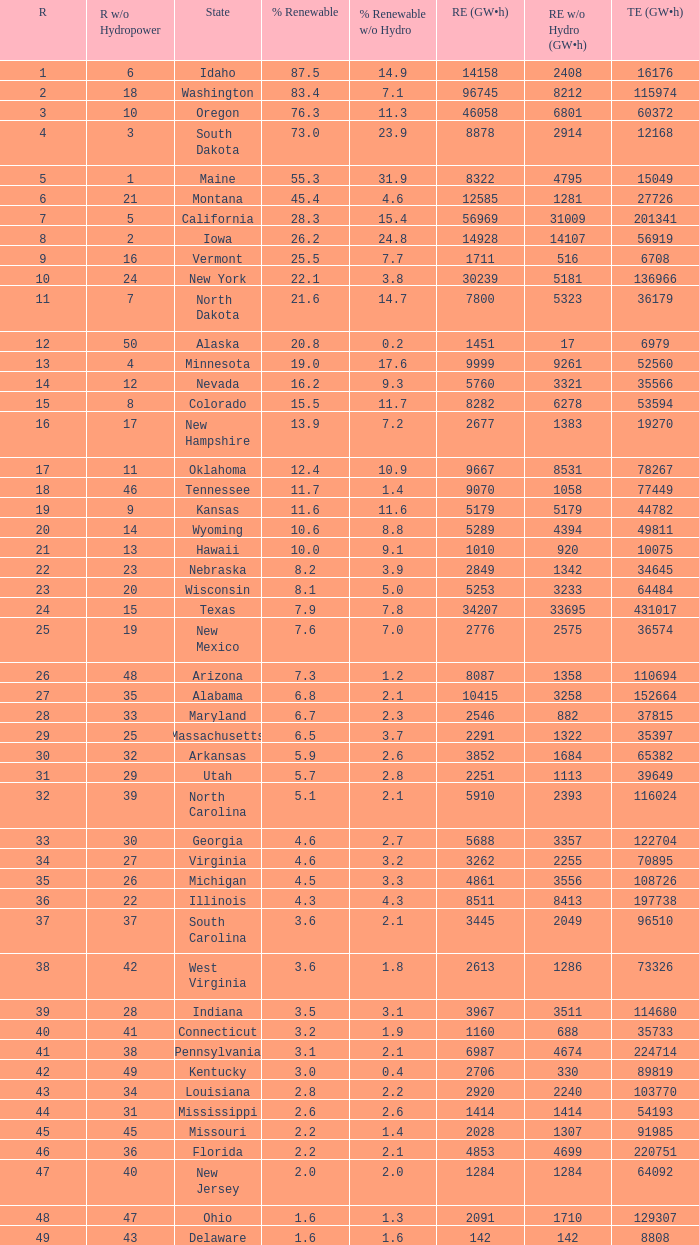What is the amount of renewable electricity without hydrogen power when the percentage of renewable energy is 83.4? 8212.0. 